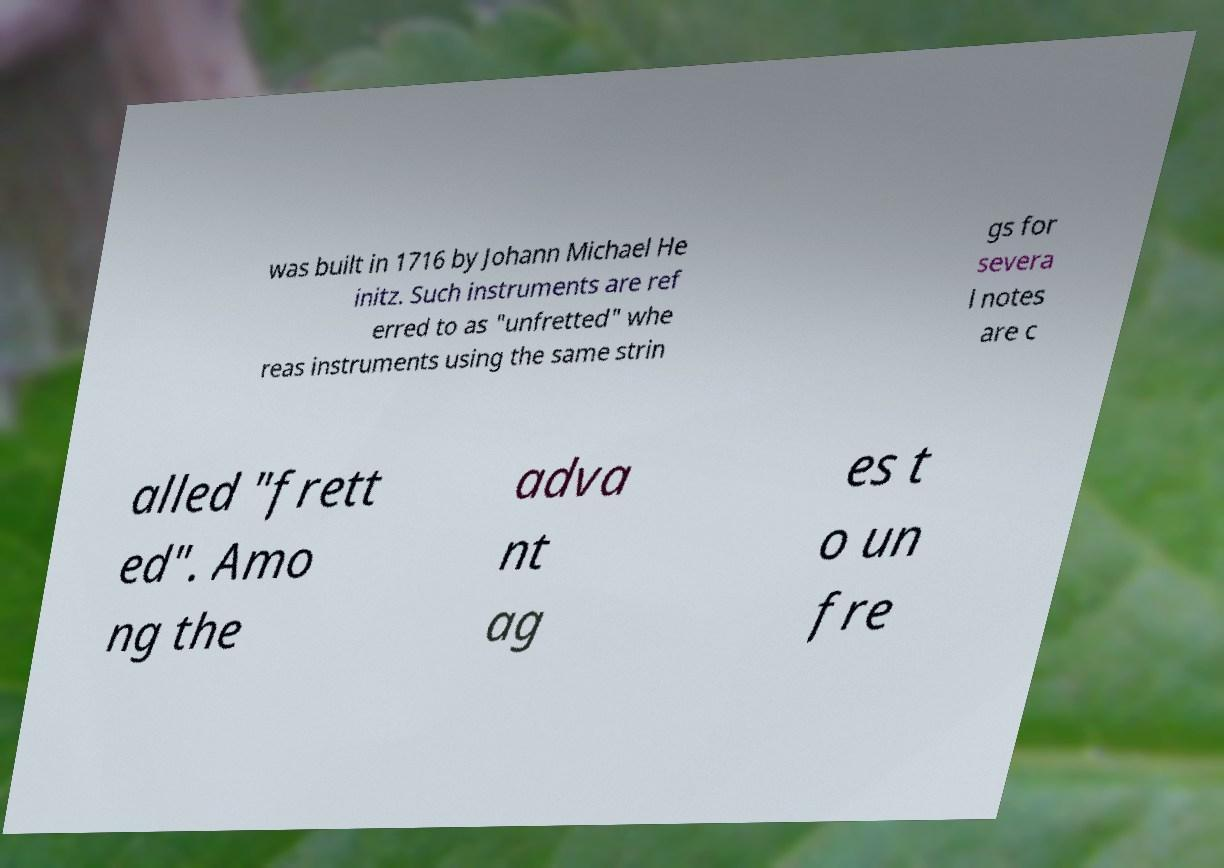Could you assist in decoding the text presented in this image and type it out clearly? was built in 1716 by Johann Michael He initz. Such instruments are ref erred to as "unfretted" whe reas instruments using the same strin gs for severa l notes are c alled "frett ed". Amo ng the adva nt ag es t o un fre 